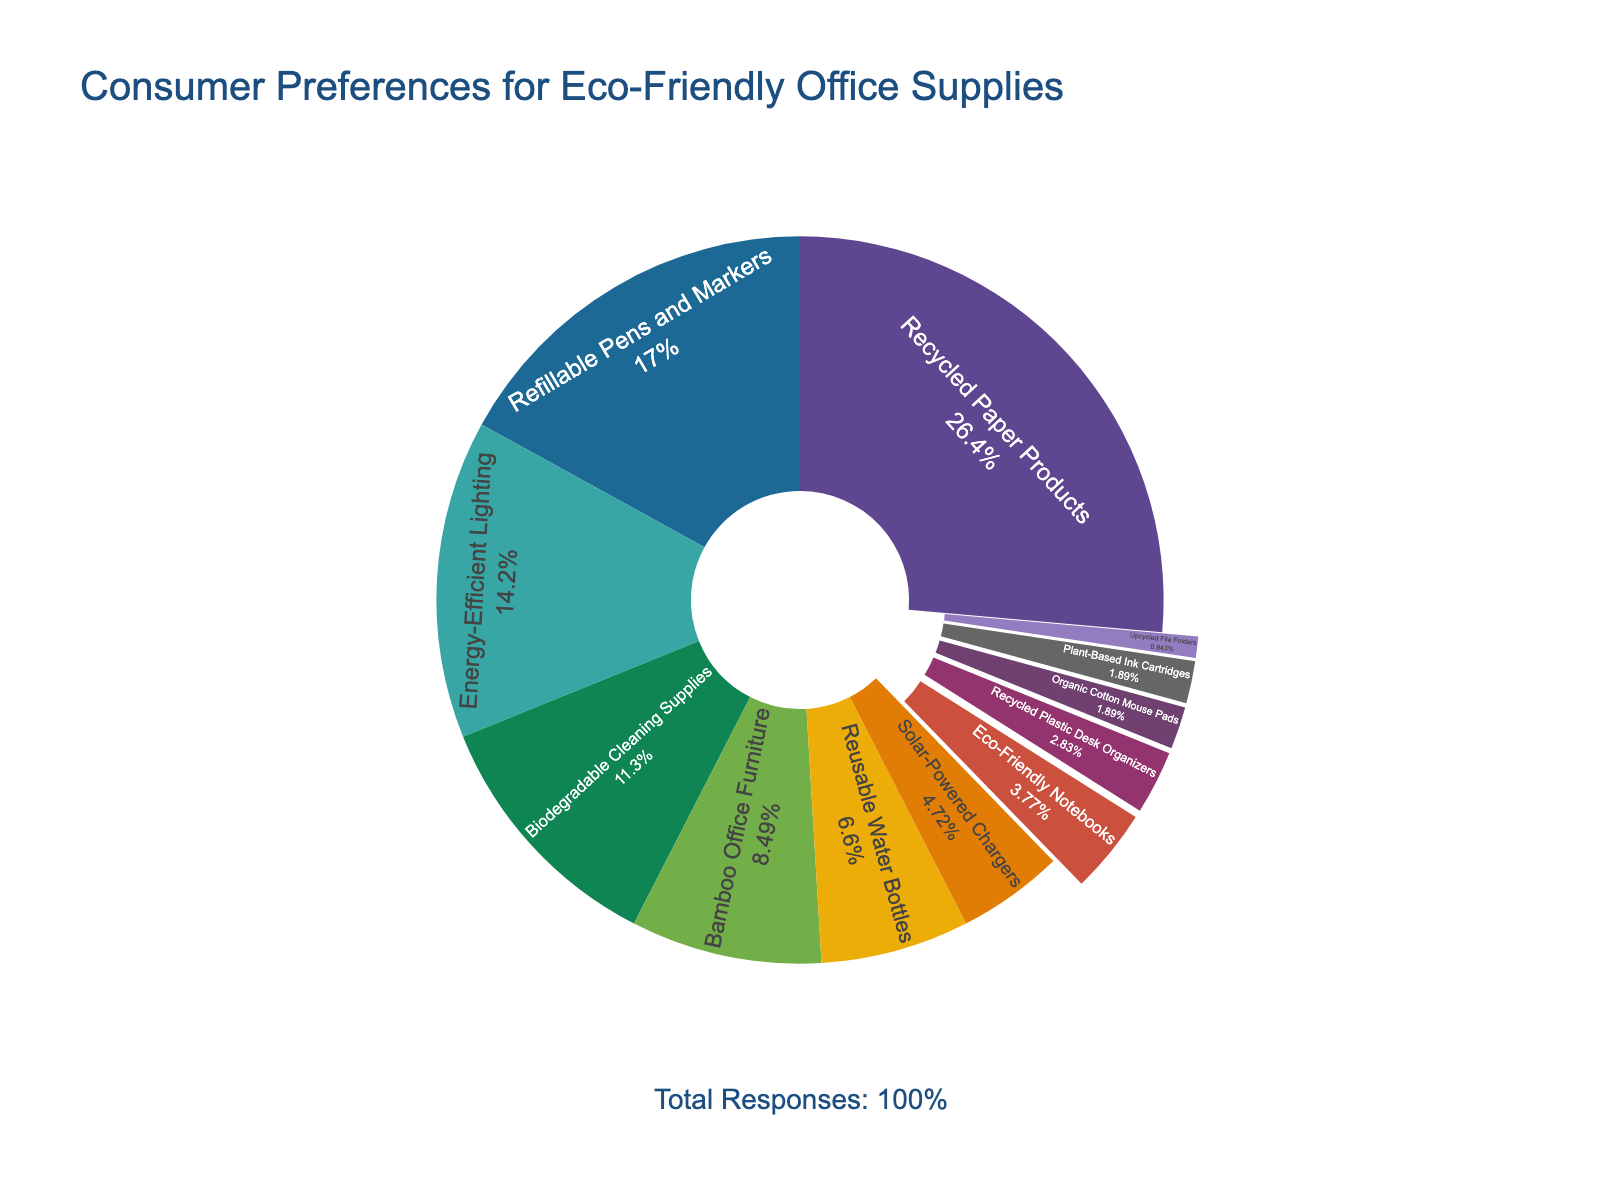What is the most preferred category of eco-friendly office supplies? Look for the category with the largest section in the pie chart. "Recycled Paper Products" has the largest section at 28%.
Answer: Recycled Paper Products Which category is least preferred by consumers? Identify the smallest section of the pie chart, which is "Upcycled File Folders" at 1%.
Answer: Upcycled File Folders How do the preferences for Recycled Paper Products and Refillable Pens and Markers compare? Recycled Paper Products has a larger percentage (28%) compared to Refillable Pens and Markers (18%).
Answer: Recycled Paper Products is more preferred What's the combined percentage of Biodegradable Cleaning Supplies and Bamboo Office Furniture? Add the percentages of the two categories: 12% (Biodegradable Cleaning Supplies) + 9% (Bamboo Office Furniture) = 21%.
Answer: 21% What percentage of consumers prefer categories with 5% or lower? Add the percentages of Solar-Powered Chargers (5%), Eco-Friendly Notebooks (4%), Recycled Plastic Desk Organizers (3%), Organic Cotton Mouse Pads (2%), Plant-Based Ink Cartridges (2%), and Upcycled File Folders (1%): 5% + 4% + 3% + 2% + 2% + 1% = 17%.
Answer: 17% Which category has a larger share: Energy-Efficient Lighting or Biodegradable Cleaning Supplies? Compare the percentages of Energy-Efficient Lighting (15%) and Biodegradable Cleaning Supplies (12%). Energy-Efficient Lighting has a larger share.
Answer: Energy-Efficient Lighting How much more preferred are Recycled Paper Products compared to Energy-Efficient Lighting? Subtract the percentage of Energy-Efficient Lighting from Recycled Paper Products: 28% - 15% = 13%.
Answer: 13% What is the average percentage preference for categories with more than 10%? Identify the relevant categories: Recycled Paper Products (28%), Refillable Pens and Markers (18%), and Energy-Efficient Lighting (15%). Calculate their average: (28% + 18% + 15%) / 3 = 20.33%.
Answer: 20.33% By what factor is the preference for Reusable Water Bottles higher than for Plant-Based Ink Cartridges? Divide the percentage of Reusable Water Bottles by Plant-Based Ink Cartridges: 7% / 2% = 3.5.
Answer: 3.5 